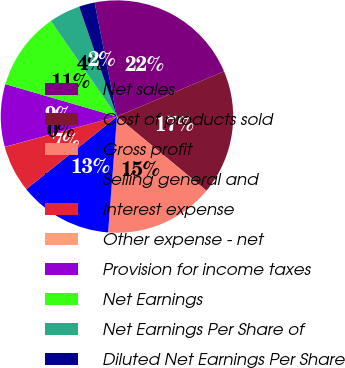Convert chart to OTSL. <chart><loc_0><loc_0><loc_500><loc_500><pie_chart><fcel>Net sales<fcel>Cost of products sold<fcel>Gross profit<fcel>Selling general and<fcel>Interest expense<fcel>Other expense - net<fcel>Provision for income taxes<fcel>Net Earnings<fcel>Net Earnings Per Share of<fcel>Diluted Net Earnings Per Share<nl><fcel>21.72%<fcel>17.38%<fcel>15.21%<fcel>13.04%<fcel>6.53%<fcel>0.02%<fcel>8.7%<fcel>10.87%<fcel>4.36%<fcel>2.19%<nl></chart> 